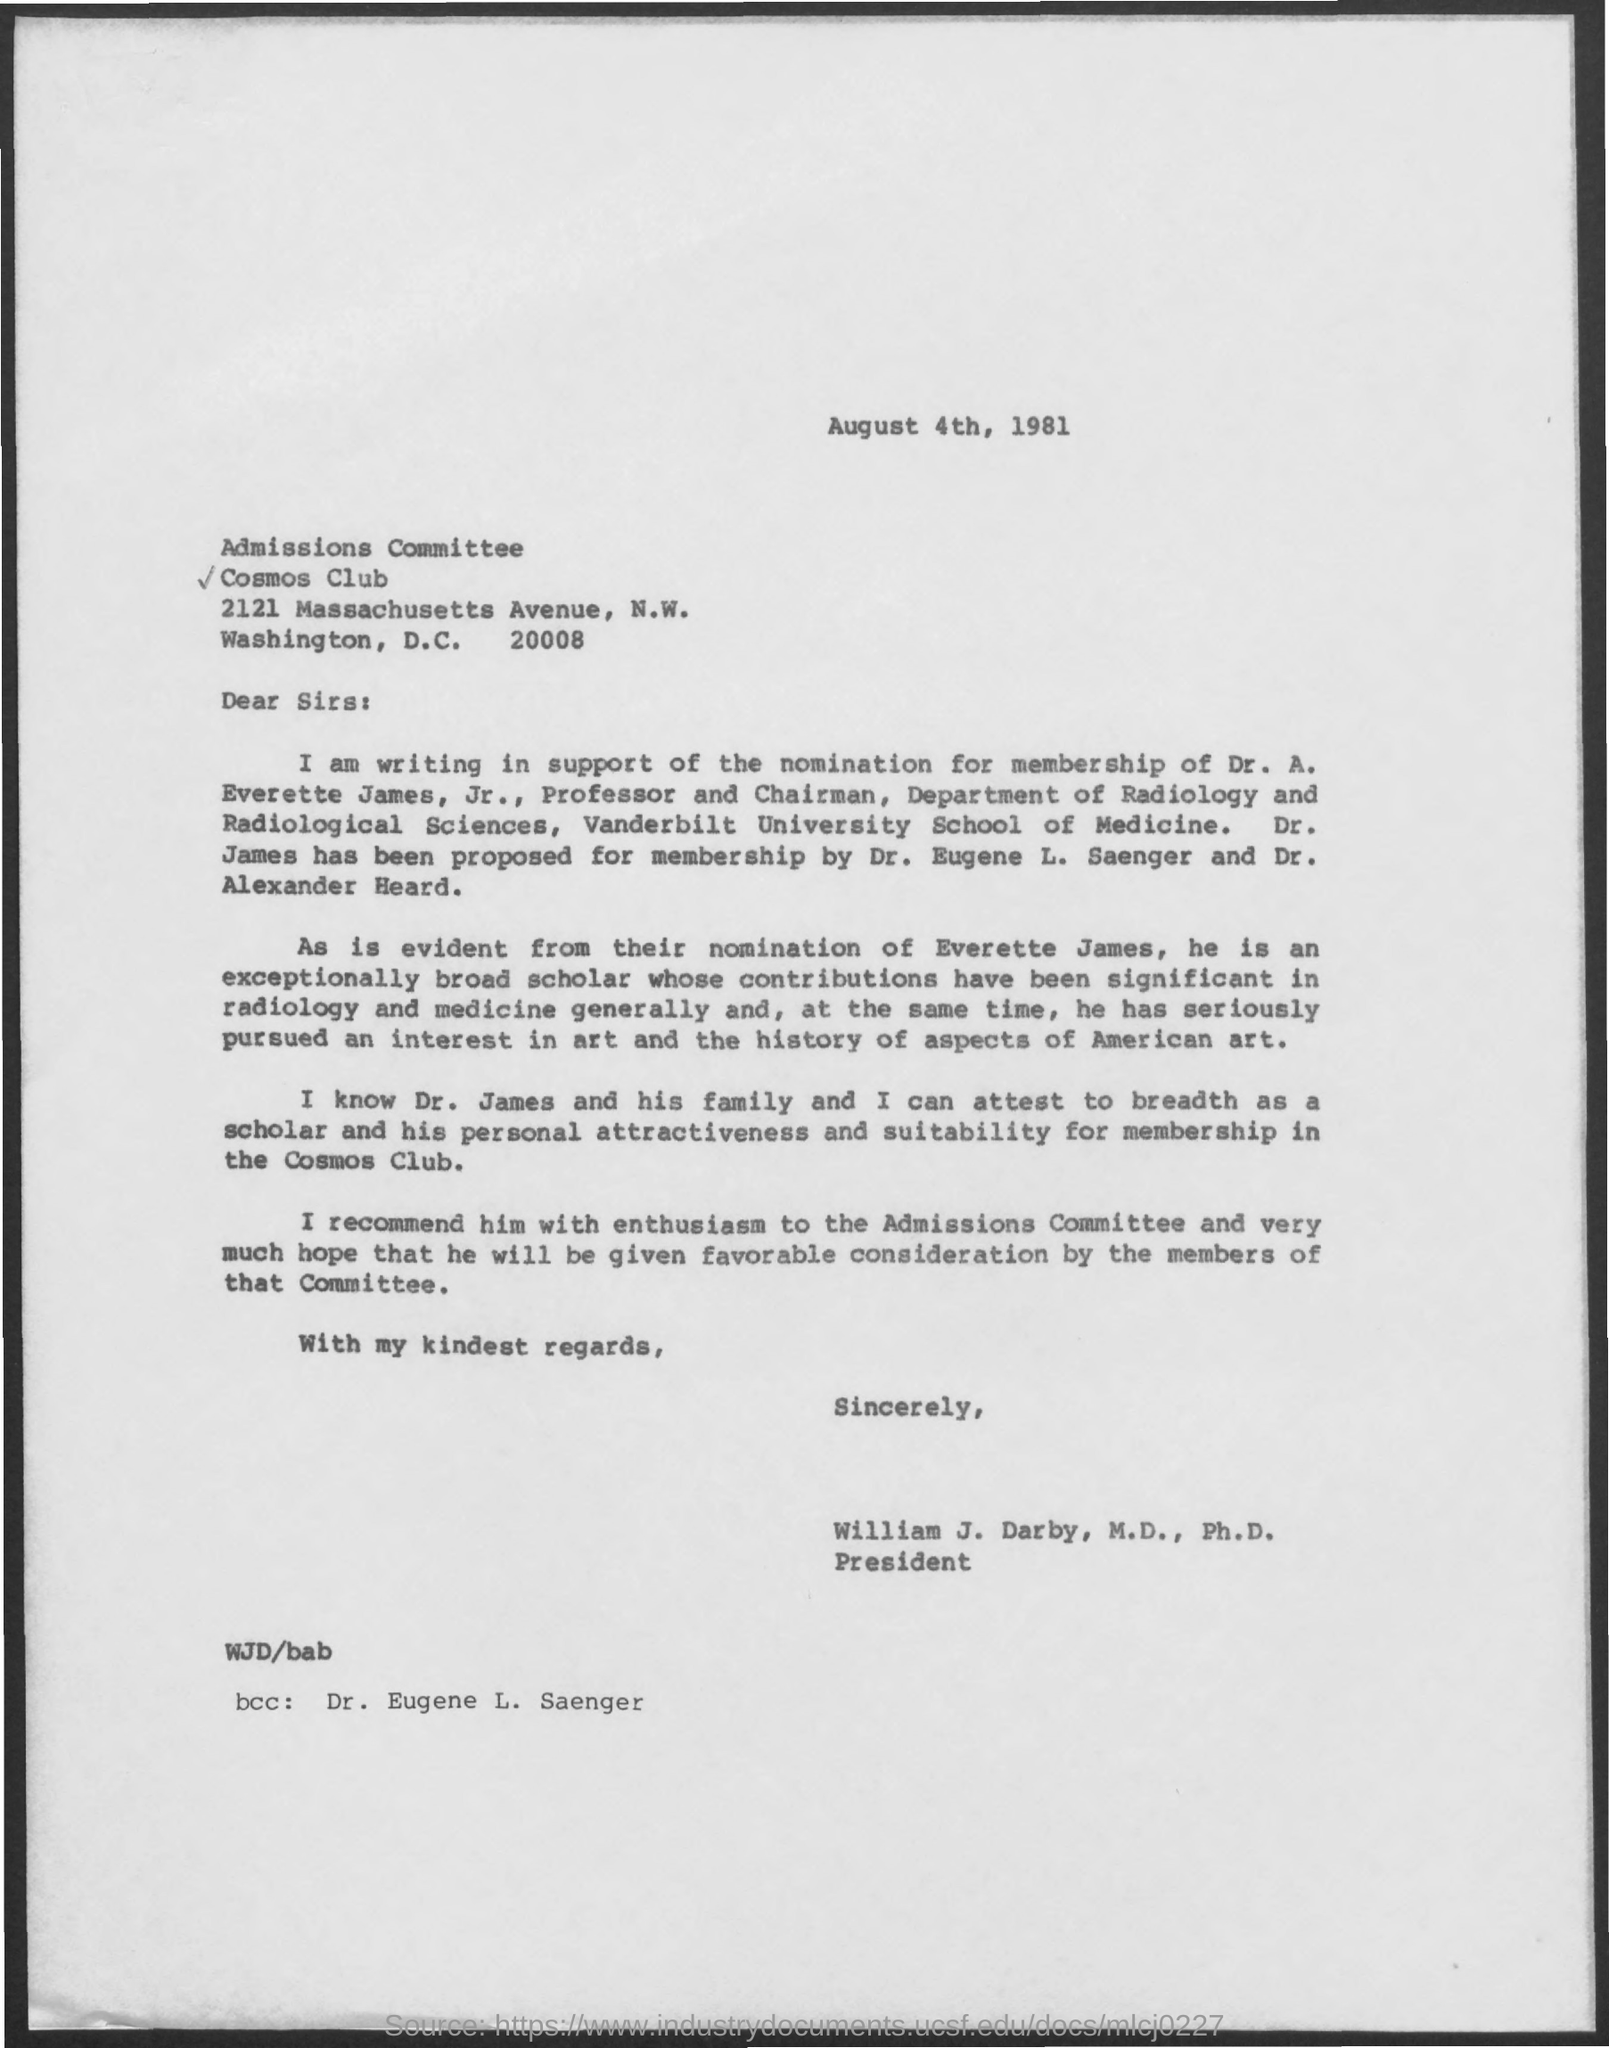When is the Memorandum dated on ?
Offer a very short reply. August 4th, 1981. Who is the "bcc" ?
Your answer should be very brief. Dr. Eugene L. Saenger. 